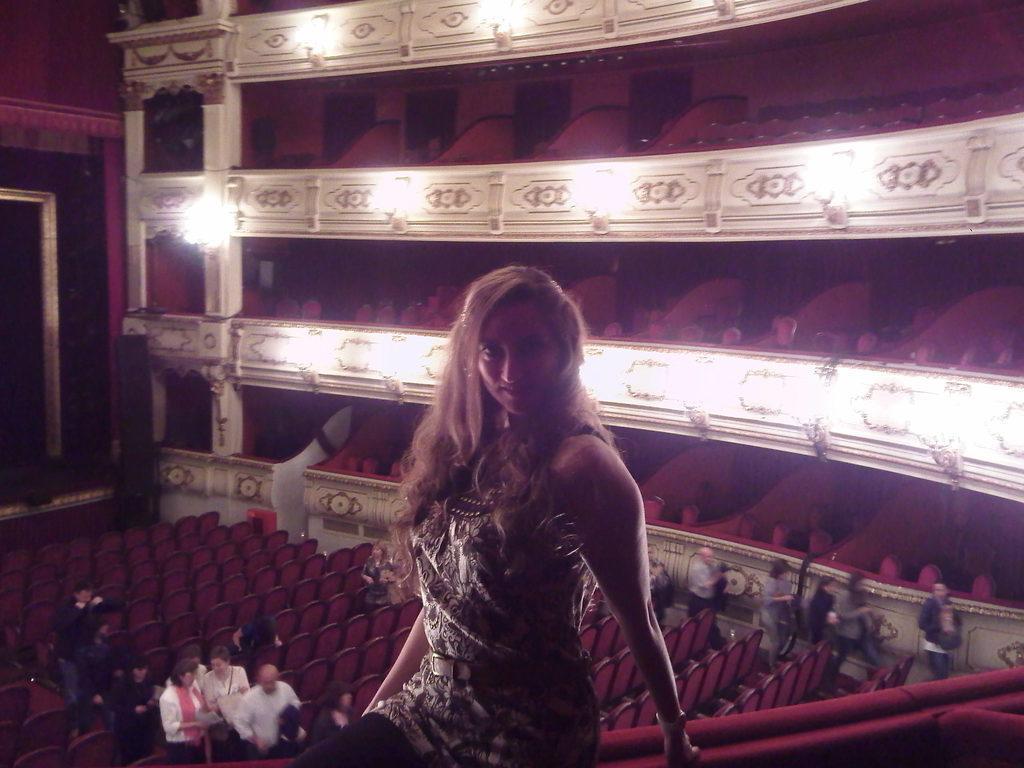Describe this image in one or two sentences. In this image I can see a woman sitting. Also there are group of people, there are chairs, pillars, lights and there are some other objects. 